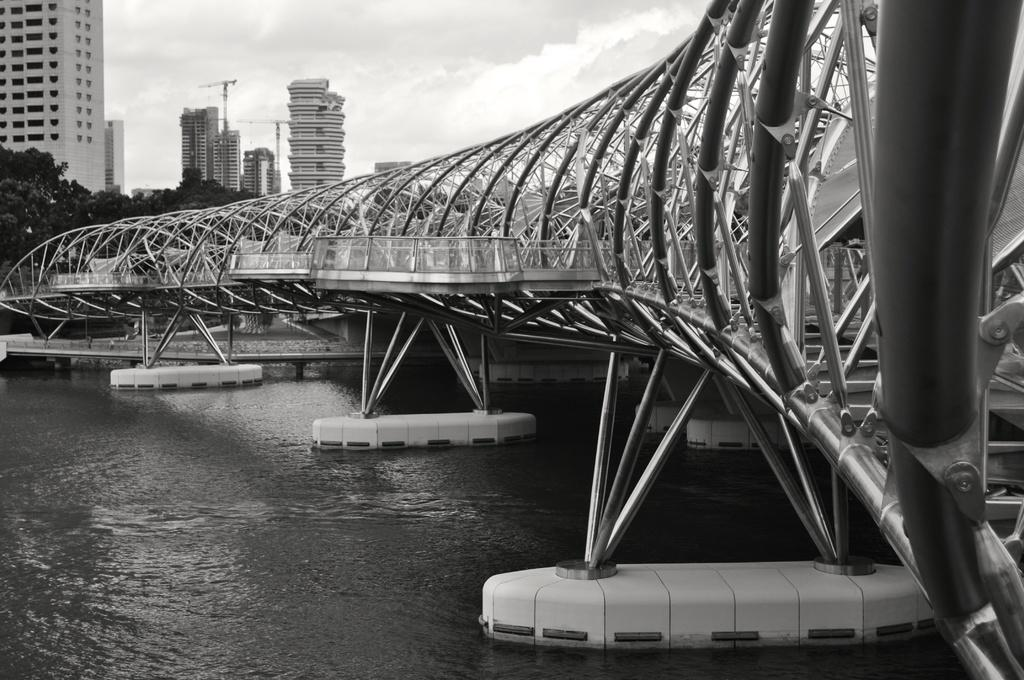What is the primary element visible in the image? There is water in the image. What type of man-made structures can be seen in the image? There are buildings in the image. What type of natural elements are present in the image? There are trees in the image. What type of structure made of metal can be seen in the image? There is an iron structure in the image. What is visible in the background of the image? The sky is visible in the image. What type of polish is being applied to the trees in the image? There is no indication in the image that any polish is being applied to the trees. How many dust particles can be seen floating in the water in the image? There is no way to determine the number of dust particles in the water from the image. 